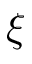Convert formula to latex. <formula><loc_0><loc_0><loc_500><loc_500>\xi</formula> 